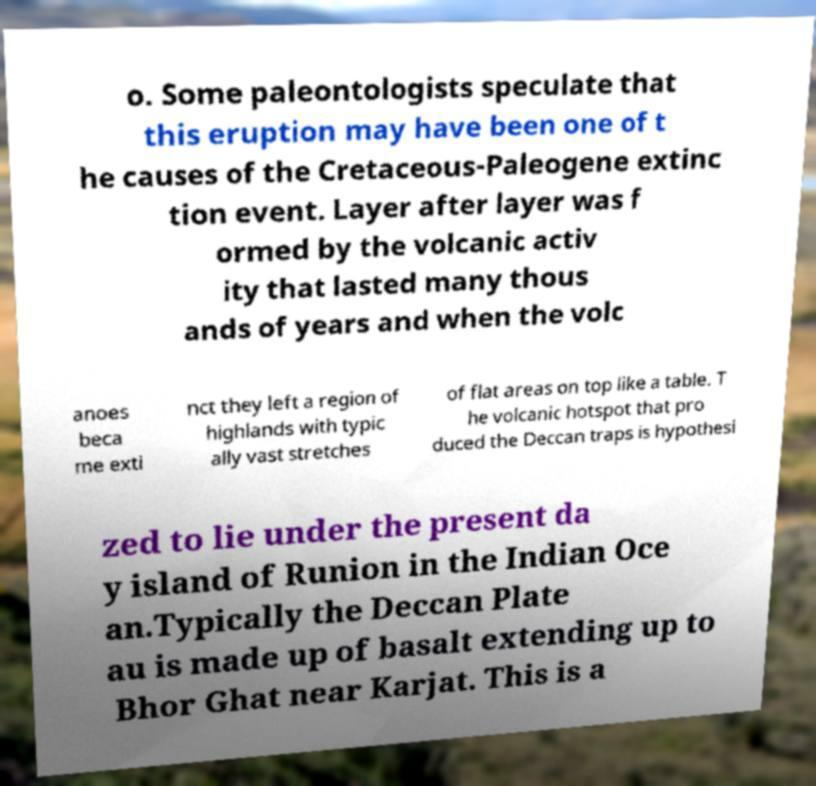Please read and relay the text visible in this image. What does it say? o. Some paleontologists speculate that this eruption may have been one of t he causes of the Cretaceous-Paleogene extinc tion event. Layer after layer was f ormed by the volcanic activ ity that lasted many thous ands of years and when the volc anoes beca me exti nct they left a region of highlands with typic ally vast stretches of flat areas on top like a table. T he volcanic hotspot that pro duced the Deccan traps is hypothesi zed to lie under the present da y island of Runion in the Indian Oce an.Typically the Deccan Plate au is made up of basalt extending up to Bhor Ghat near Karjat. This is a 